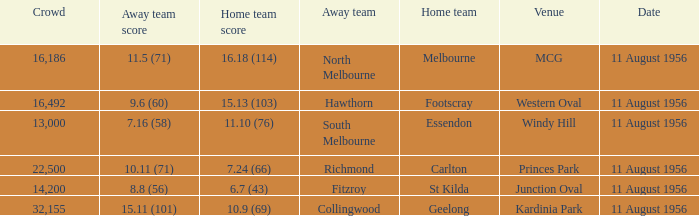9 (69)? Kardinia Park. 